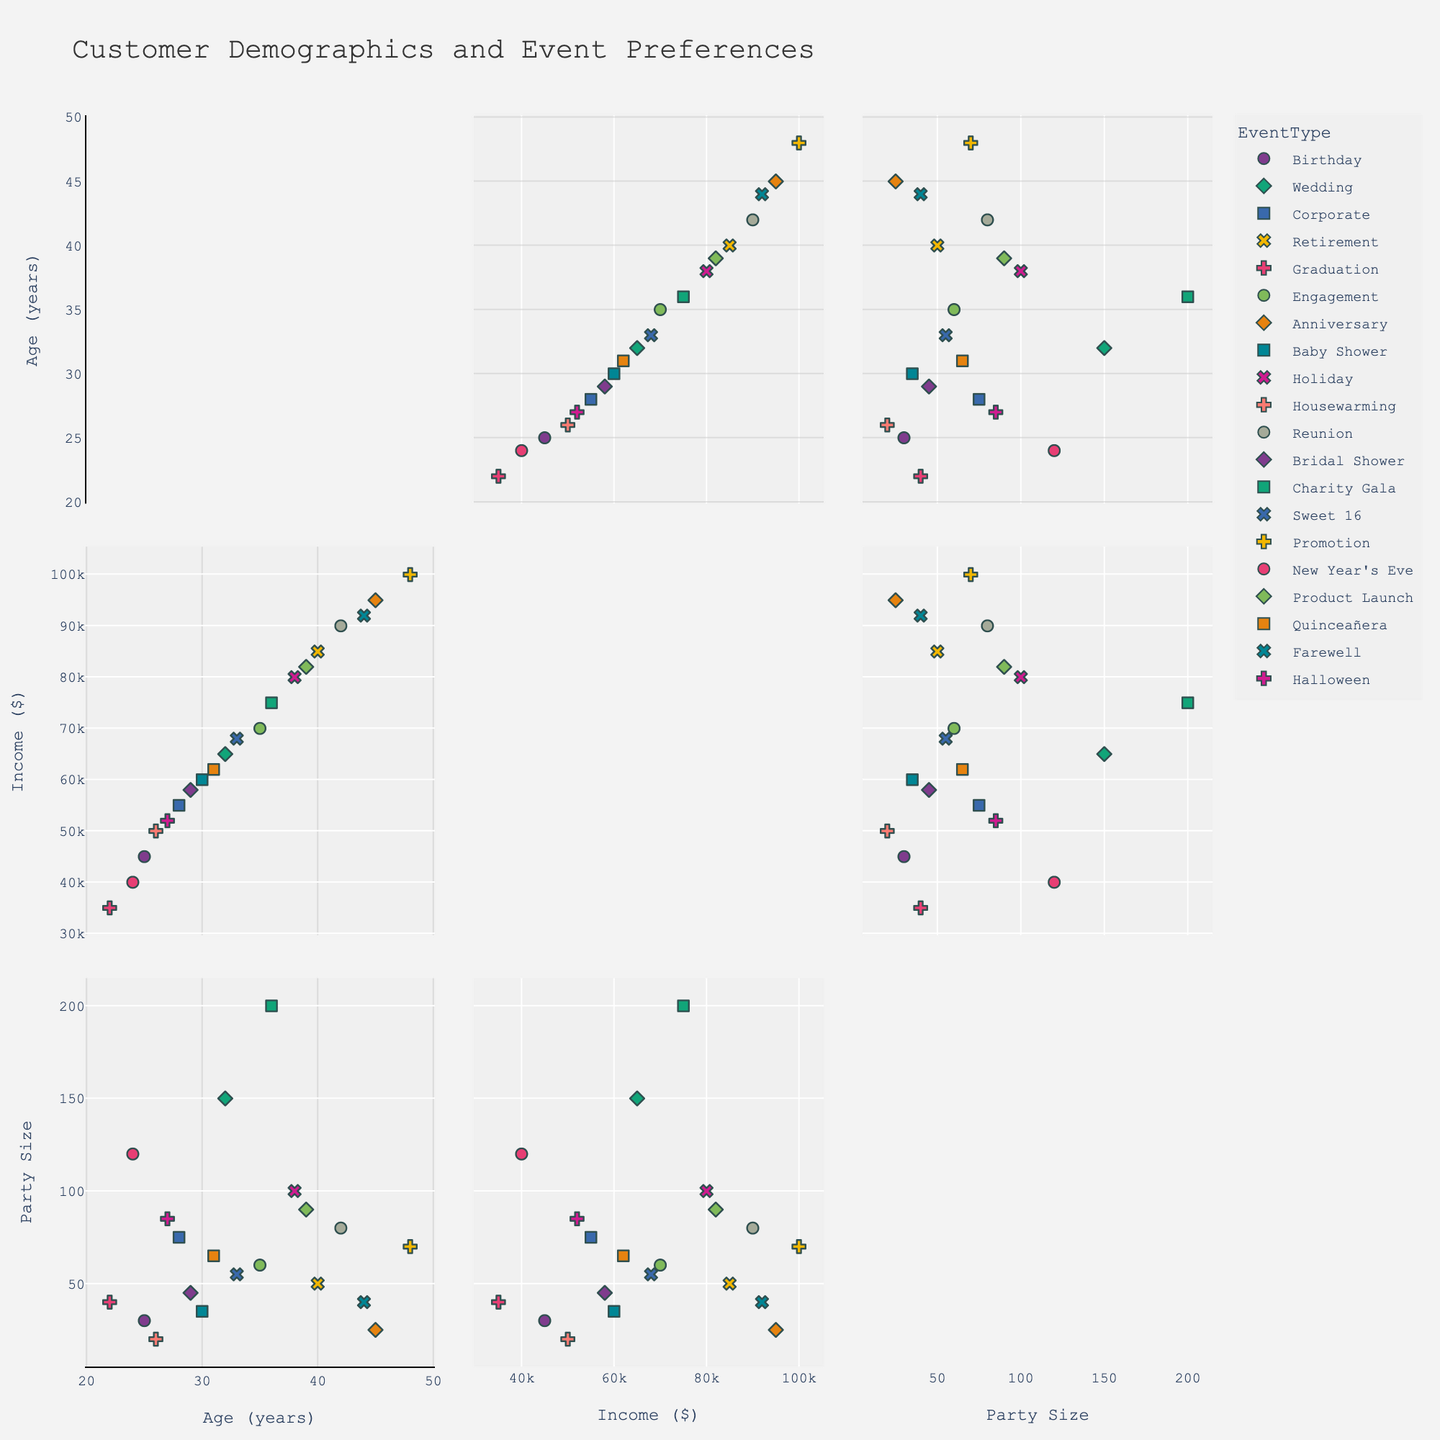What is the title of the scatterplot matrix? The title is usually found at the top of the plot and provides an overview of what the plot represents.
Answer: Customer Demographics and Event Preferences What dimensions are included in the scatterplot matrix? The dimensions are typically labeled on the axes; in this case, they are Age, Income, and Party Size.
Answer: Age, Income, Party Size How many colors are used to represent different Event Types? The plot uses different colors for each Event Type, shown in the legend. Counting the unique colors will give the answer.
Answer: 20 Which Event Type has the highest income and what is that income? By looking for the dot positioned highest on the Income axis and identifying its Event Type.
Answer: Promotion, $100,000 What’s the average age of customers who plan Birthday events? Identify all Birthday event points, sum their ages, and divide by the number of points.
Answer: (25) / 1 = 25 How does the party size for Corporate events compare to Birthday events? Identify and compare the Party Size for Corporate and Birthday events based on their positions along the PartySize axis.
Answer: Corporate: 75, Birthday: 30 What is the income range for Wedding events? Identify Wedding event points and note the minimum and maximum positions on the Income axis.
Answer: $65,000 - $65,000 Which Event Type has the smallest Party Size and what is that size? Find the point with the smallest value on the PartySize axis and check its Event Type.
Answer: Housewarming, 20 For events with an Income of $80,000, what is the range of Party Sizes? Locate all points at $80,000 Income, then identify their corresponding PartySize values.
Answer: 100 Are there any Event Types that have overlapping data points in terms of Income and Party Size? Look for multiple points (Event Types) that share the same or very close values for both Income and Party Size.
Answer: Yes, Promotion and Product Launch overlap in the middle of the plot around Party Size 70-90 and Income $80,000-$100,000 